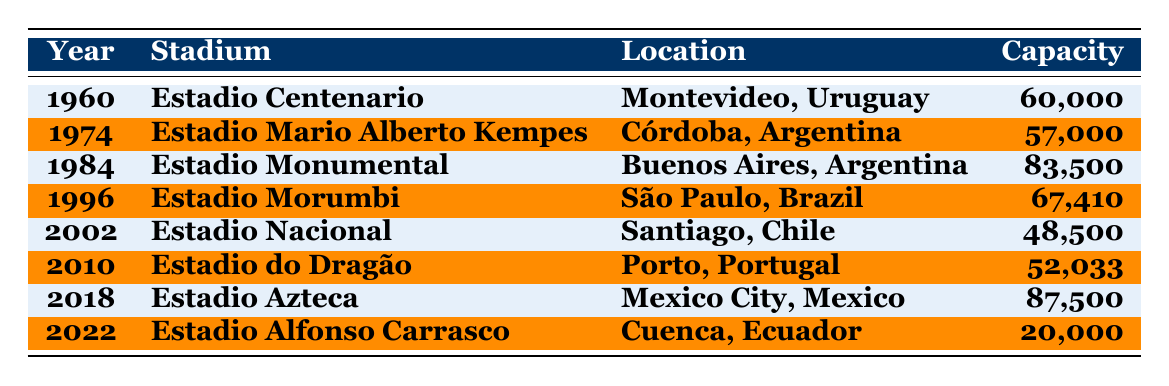What stadium had the highest capacity in Copa Ramírez history? By analyzing the "Capacity" column in the table, Estadio Monumental with a capacity of 83,500 has the highest capacity among the listed stadiums.
Answer: Estadio Monumental Which year featured Estadio Azteca as the match location? Searching the table, Estadio Azteca is associated with the year 2018.
Answer: 2018 How many matches took place in Argentina? By counting the rows, there are three matches in Argentina: Estadio Mario Alberto Kempes (1974), Estadio Monumental (1984), and one match in Cuenca, Ecuador.
Answer: 3 What is the total capacity of all the stadiums listed? Adding the capacities: 60,000 + 57,000 + 83,500 + 67,410 + 48,500 + 52,033 + 87,500 + 20,000 = 435,943.
Answer: 435,943 Was Estadio Nacional utilized in a year after 2000? The table shows Estadio Nacional was utilized in 2002, which is after the year 2000.
Answer: Yes Which stadium had a capacity smaller than 50,000? Looking at the capacities, Estadio Alfonso Carrasco (20,000) has a capacity smaller than 50,000.
Answer: Estadio Alfonso Carrasco What is the difference in capacity between Estadio Centenario and Estadio Morumbi? The capacities are 60,000 for Estadio Centenario and 67,410 for Estadio Morumbi. The difference is 67,410 - 60,000 = 7,410.
Answer: 7,410 Which location hosted the biggest match in terms of stadium capacity? Estadio Azteca in Mexico City, with a capacity of 87,500, hosted the largest match according to the capacity column.
Answer: Mexico City, Mexico How many stadiums are located in Brazil? There is only one stadium listed in Brazil, which is the Estadio Morumbi in São Paulo.
Answer: 1 In which year was the stadium with the second largest capacity utilized? The second largest capacity is 83,500 for Estadio Monumental, which was utilized in 1984.
Answer: 1984 